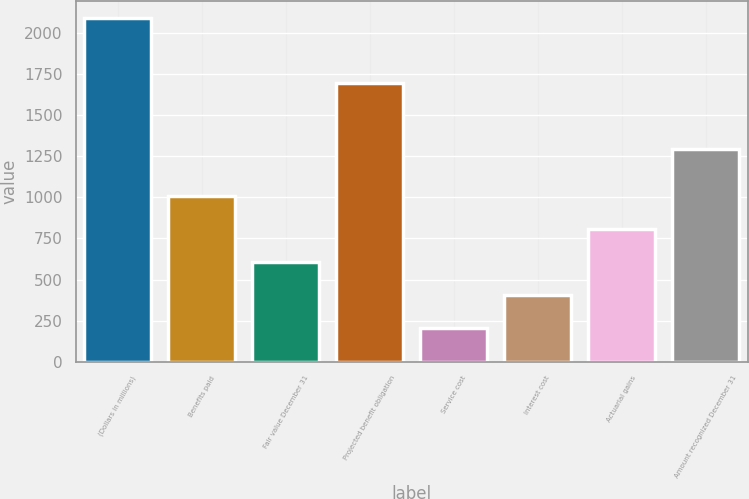<chart> <loc_0><loc_0><loc_500><loc_500><bar_chart><fcel>(Dollars in millions)<fcel>Benefits paid<fcel>Fair value December 31<fcel>Projected benefit obligation<fcel>Service cost<fcel>Interest cost<fcel>Actuarial gains<fcel>Amount recognized December 31<nl><fcel>2094.8<fcel>1007<fcel>606.6<fcel>1694.4<fcel>206.2<fcel>406.4<fcel>806.8<fcel>1294<nl></chart> 